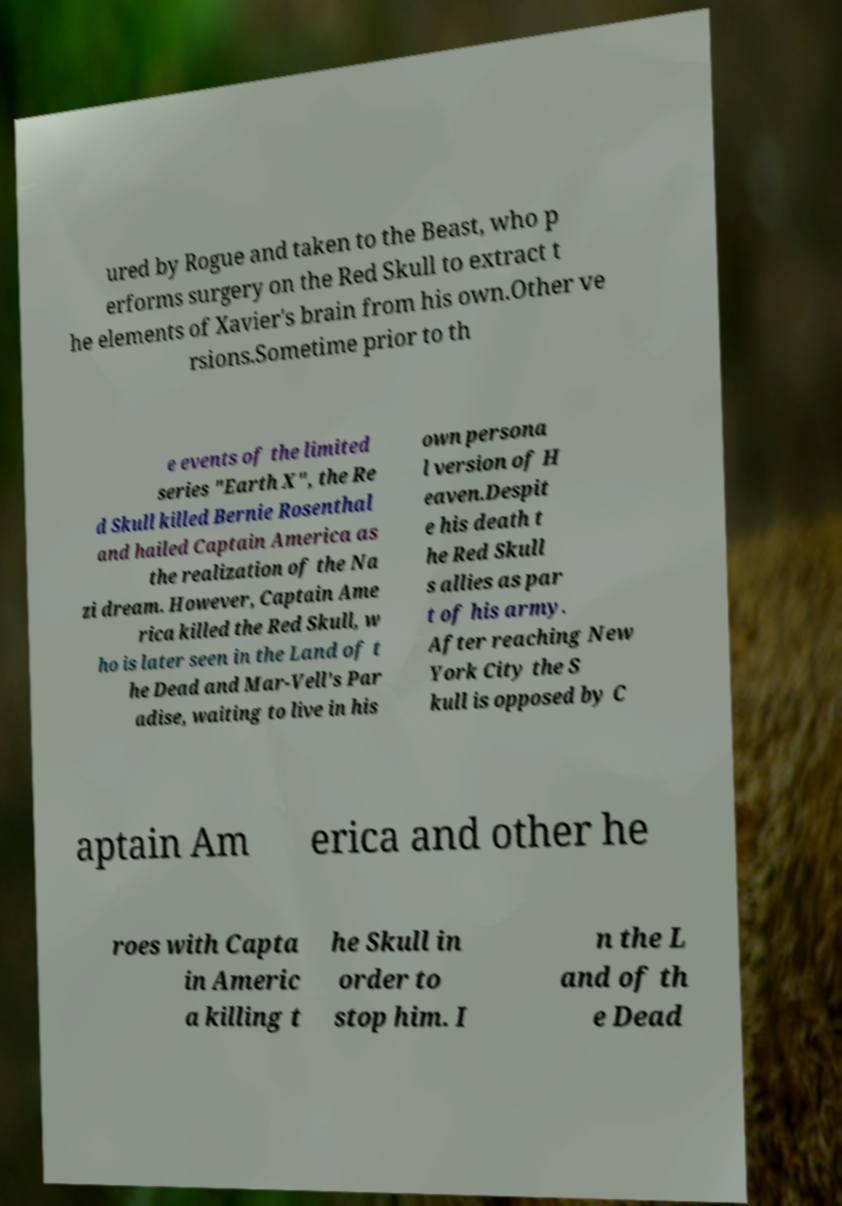Could you extract and type out the text from this image? ured by Rogue and taken to the Beast, who p erforms surgery on the Red Skull to extract t he elements of Xavier's brain from his own.Other ve rsions.Sometime prior to th e events of the limited series "Earth X", the Re d Skull killed Bernie Rosenthal and hailed Captain America as the realization of the Na zi dream. However, Captain Ame rica killed the Red Skull, w ho is later seen in the Land of t he Dead and Mar-Vell's Par adise, waiting to live in his own persona l version of H eaven.Despit e his death t he Red Skull s allies as par t of his army. After reaching New York City the S kull is opposed by C aptain Am erica and other he roes with Capta in Americ a killing t he Skull in order to stop him. I n the L and of th e Dead 